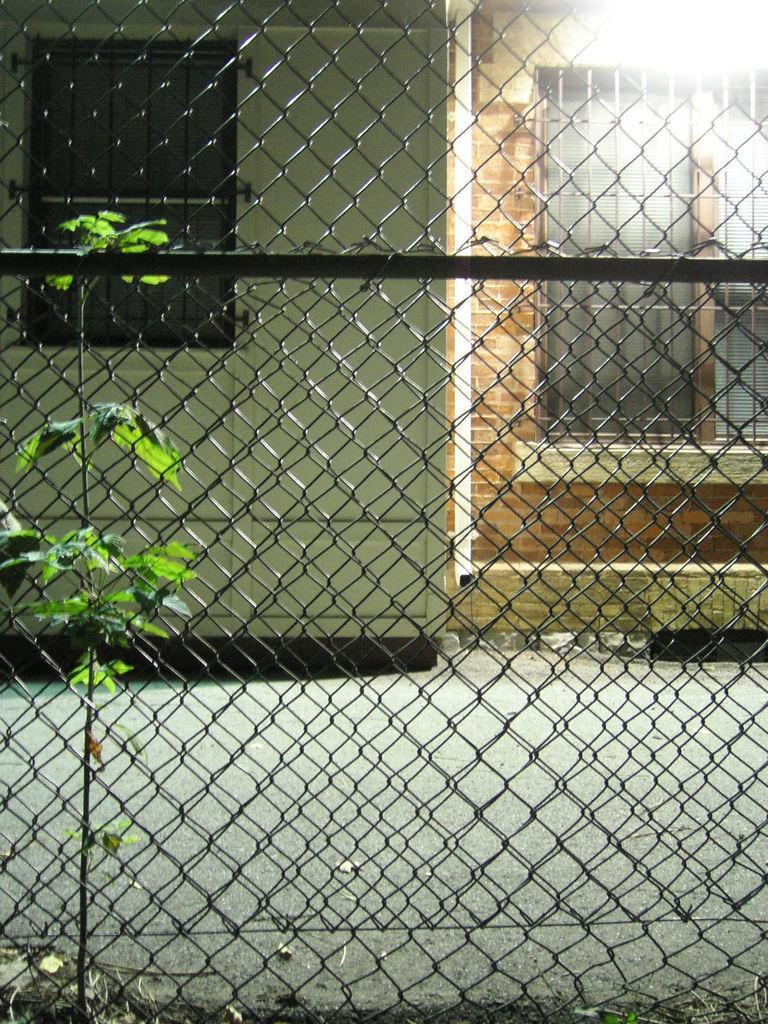Describe this image in one or two sentences. In this image, we can see a net fence. In the background, we can see a plant. In the background, we can see a metal rod, building, window and a wall. At the bottom, we can see a road. 